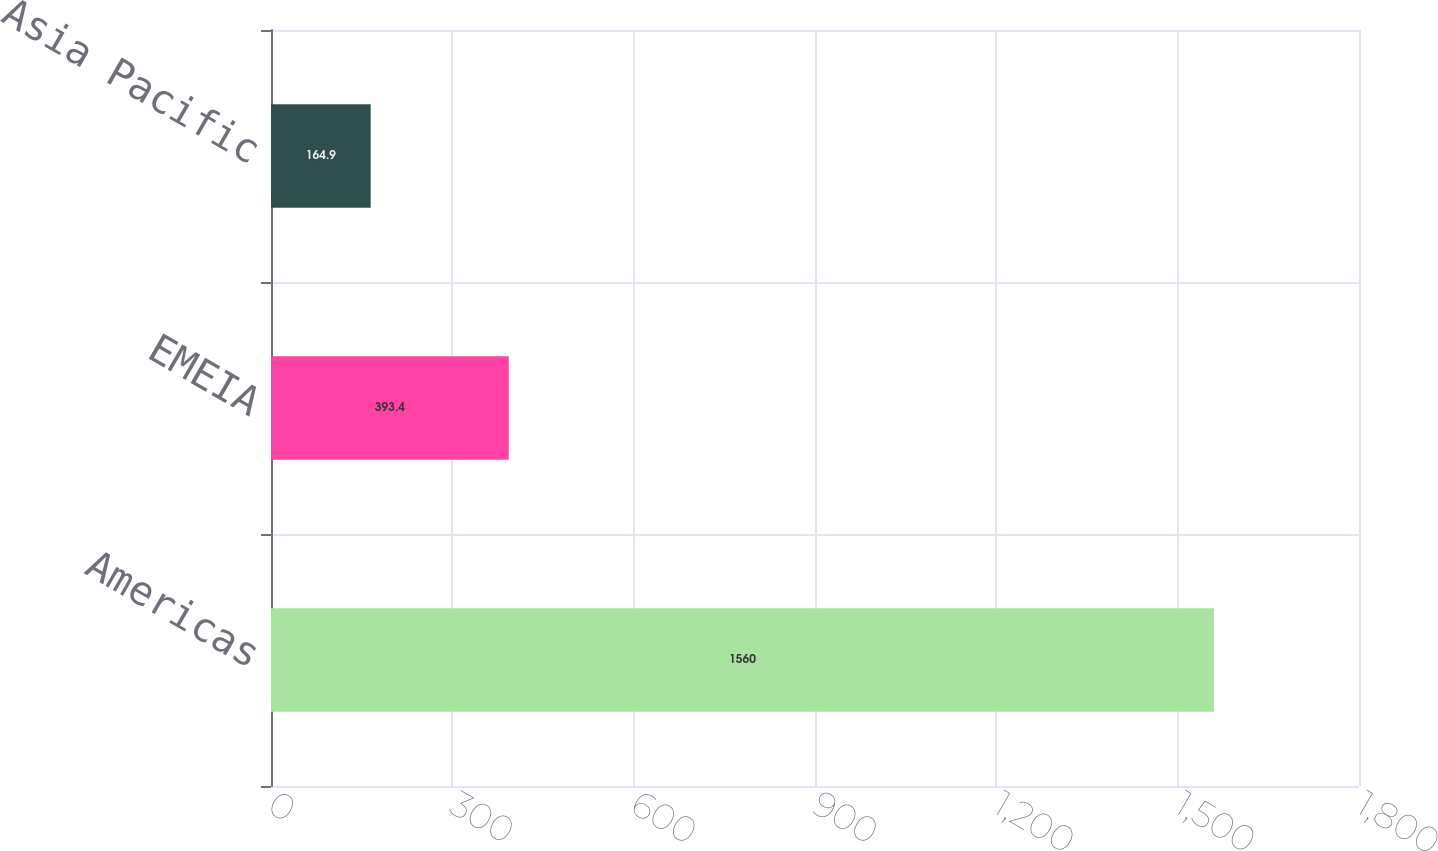<chart> <loc_0><loc_0><loc_500><loc_500><bar_chart><fcel>Americas<fcel>EMEIA<fcel>Asia Pacific<nl><fcel>1560<fcel>393.4<fcel>164.9<nl></chart> 